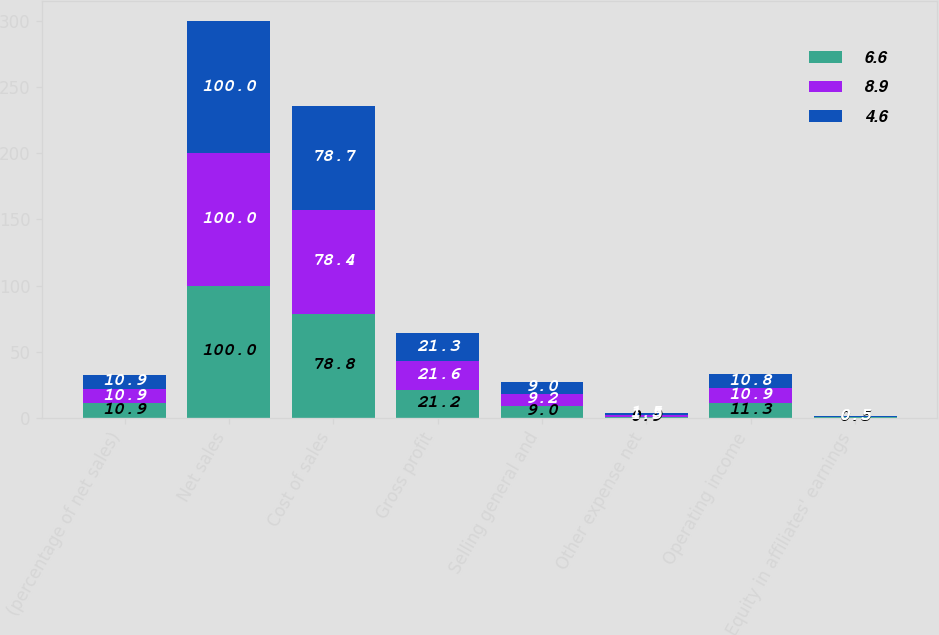Convert chart to OTSL. <chart><loc_0><loc_0><loc_500><loc_500><stacked_bar_chart><ecel><fcel>(percentage of net sales)<fcel>Net sales<fcel>Cost of sales<fcel>Gross profit<fcel>Selling general and<fcel>Other expense net<fcel>Operating income<fcel>Equity in affiliates' earnings<nl><fcel>6.6<fcel>10.9<fcel>100<fcel>78.8<fcel>21.2<fcel>9<fcel>0.9<fcel>11.3<fcel>0.5<nl><fcel>8.9<fcel>10.9<fcel>100<fcel>78.4<fcel>21.6<fcel>9.2<fcel>1.5<fcel>10.9<fcel>0.5<nl><fcel>4.6<fcel>10.9<fcel>100<fcel>78.7<fcel>21.3<fcel>9<fcel>1.5<fcel>10.8<fcel>0.5<nl></chart> 